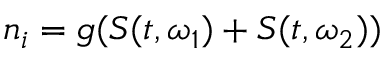<formula> <loc_0><loc_0><loc_500><loc_500>n _ { i } = g ( S ( t , \omega _ { 1 } ) + S ( t , \omega _ { 2 } ) )</formula> 